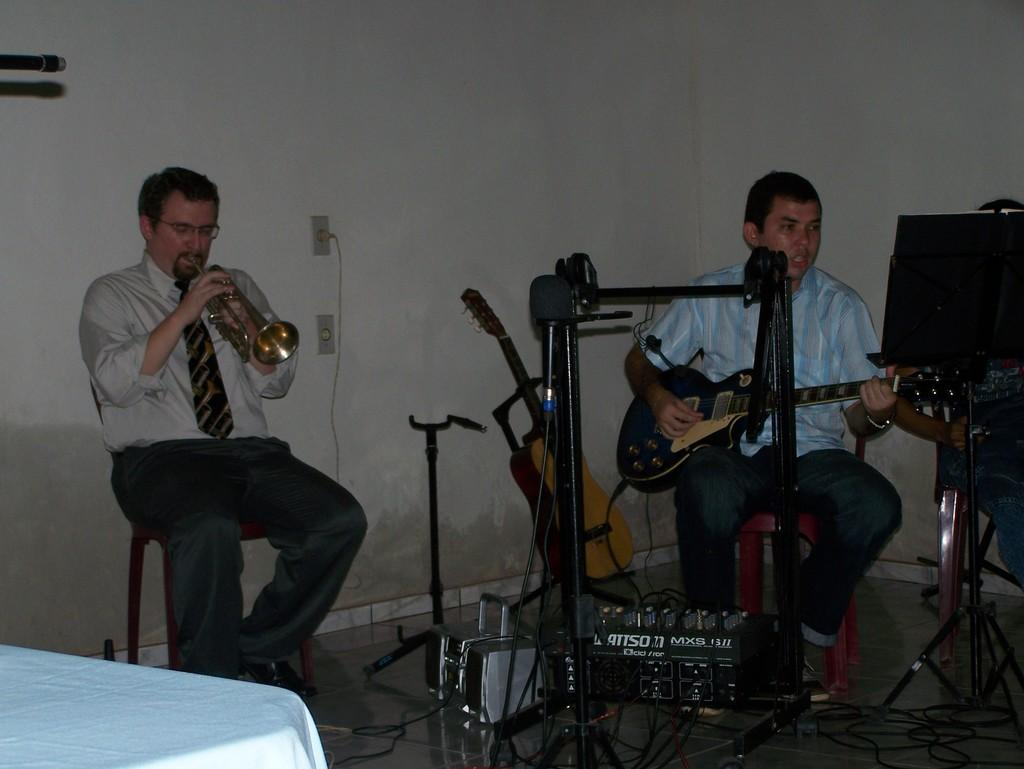How many people are in the image? There are two persons in the image. What are the persons doing in the image? The persons are sitting and holding musical instruments in their hands. What can be seen in the background of the image? There is a wall and a switch board in the background of the image. Can you see a pig playing with glue on the bed in the image? No, there is no pig, glue, or bed present in the image. 